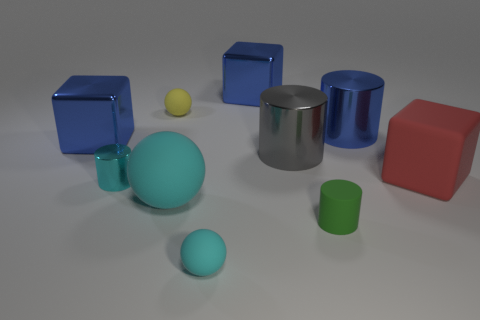Can you tell me about the lighting and the shadows in the scene? The image is illuminated by a soft, diffused light source coming from the upper left, as indicated by the gentle shadows cast on the right sides of the objects. The shadows are soft-edged, suggesting that the lighting is not harsh, and provides a calm and evenly lit scene where each object is clearly visible and defined by its silhouette. 